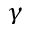Convert formula to latex. <formula><loc_0><loc_0><loc_500><loc_500>\gamma</formula> 